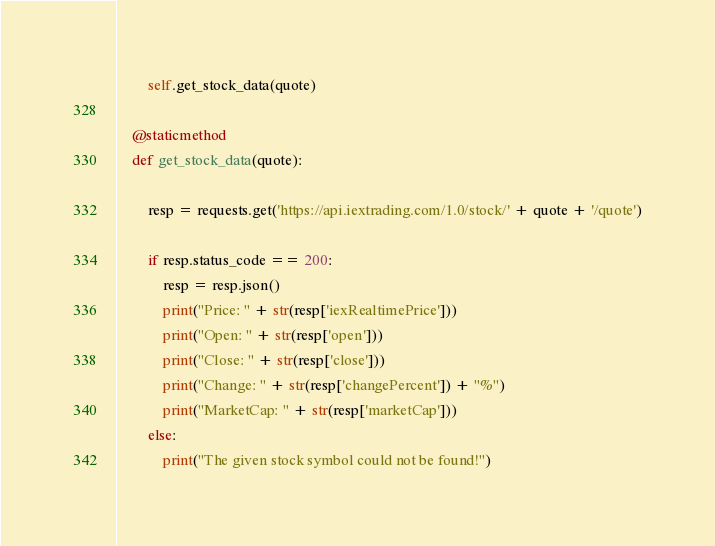Convert code to text. <code><loc_0><loc_0><loc_500><loc_500><_Python_>        self.get_stock_data(quote)

    @staticmethod
    def get_stock_data(quote):

        resp = requests.get('https://api.iextrading.com/1.0/stock/' + quote + '/quote')

        if resp.status_code == 200:
            resp = resp.json()
            print("Price: " + str(resp['iexRealtimePrice']))
            print("Open: " + str(resp['open']))
            print("Close: " + str(resp['close']))
            print("Change: " + str(resp['changePercent']) + "%")
            print("MarketCap: " + str(resp['marketCap']))
        else:
            print("The given stock symbol could not be found!")
</code> 